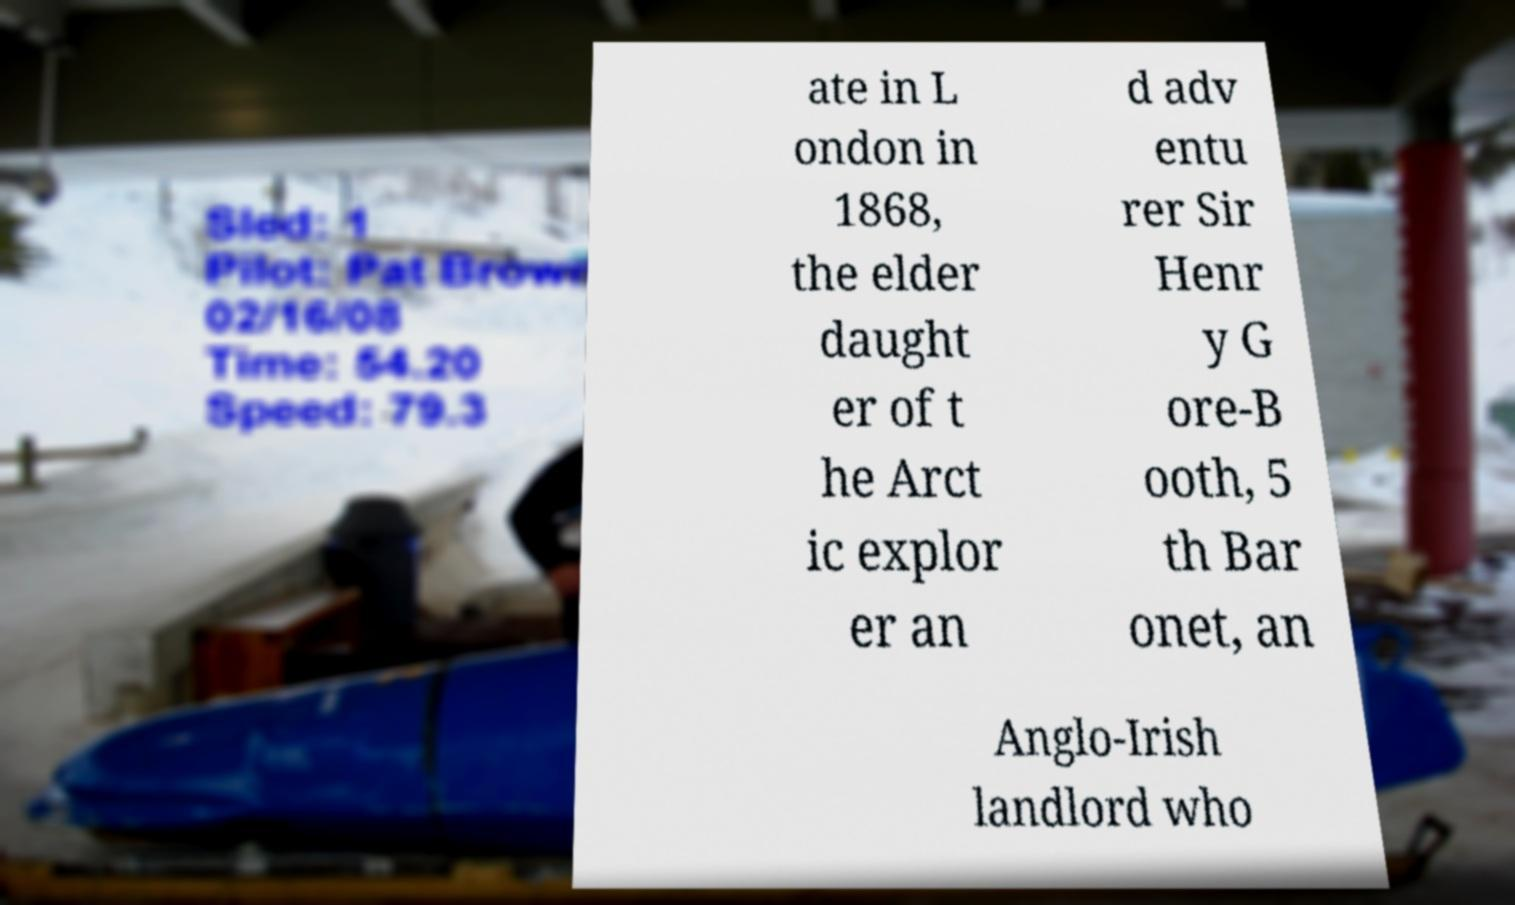Please read and relay the text visible in this image. What does it say? ate in L ondon in 1868, the elder daught er of t he Arct ic explor er an d adv entu rer Sir Henr y G ore-B ooth, 5 th Bar onet, an Anglo-Irish landlord who 